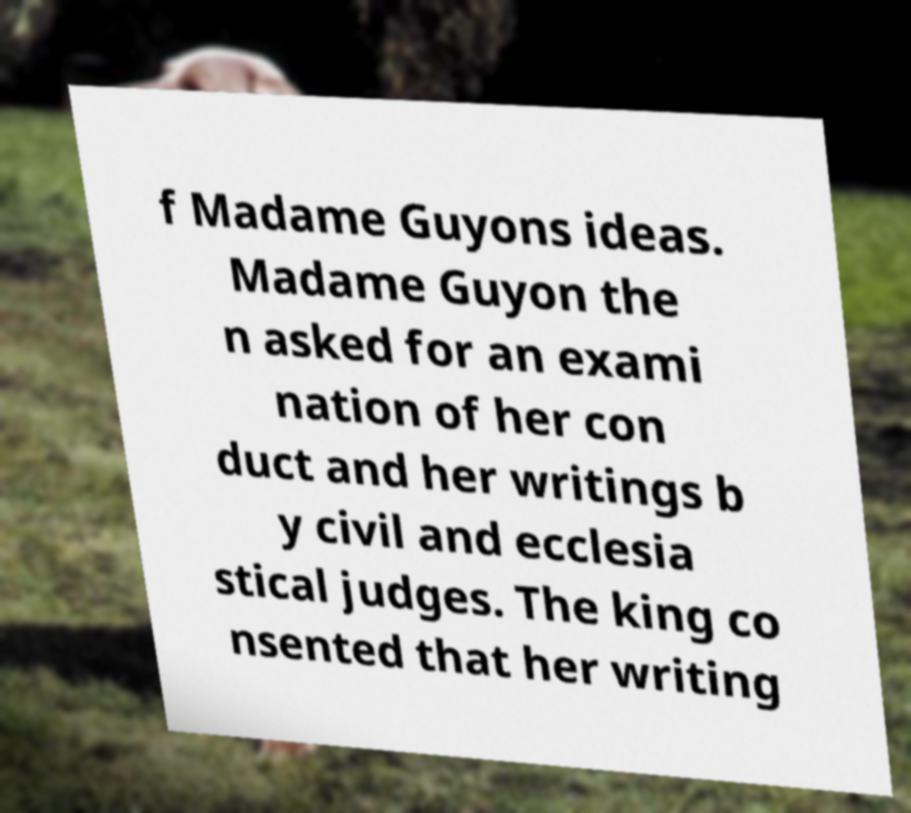Please identify and transcribe the text found in this image. f Madame Guyons ideas. Madame Guyon the n asked for an exami nation of her con duct and her writings b y civil and ecclesia stical judges. The king co nsented that her writing 